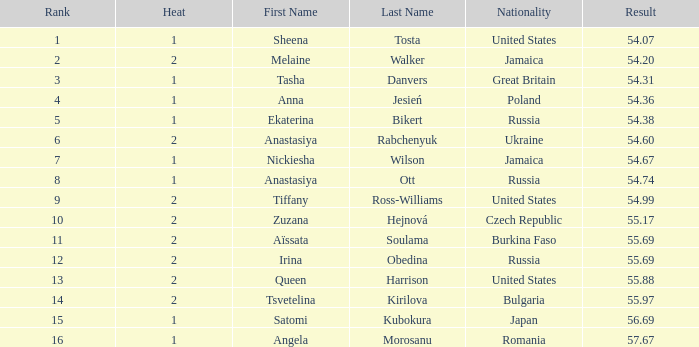Which Rank has a Name of tsvetelina kirilova, and a Result smaller than 55.97? None. 